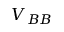<formula> <loc_0><loc_0><loc_500><loc_500>V _ { B B }</formula> 